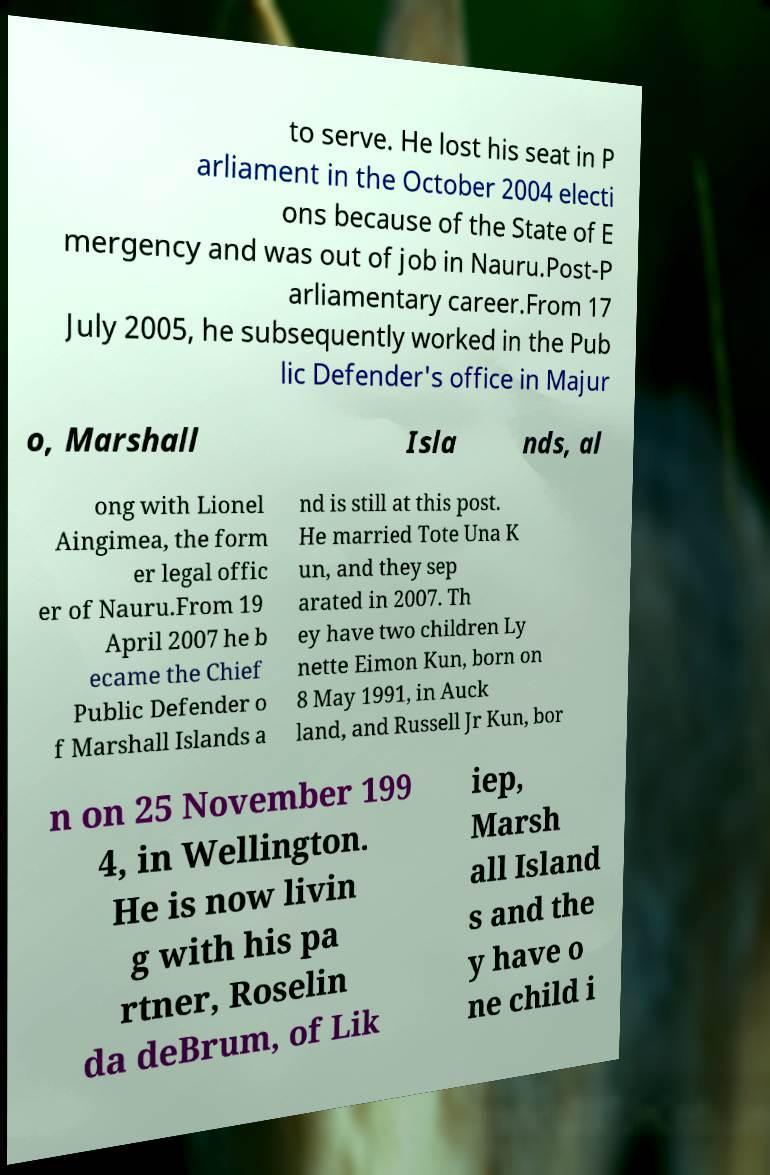For documentation purposes, I need the text within this image transcribed. Could you provide that? to serve. He lost his seat in P arliament in the October 2004 electi ons because of the State of E mergency and was out of job in Nauru.Post-P arliamentary career.From 17 July 2005, he subsequently worked in the Pub lic Defender's office in Majur o, Marshall Isla nds, al ong with Lionel Aingimea, the form er legal offic er of Nauru.From 19 April 2007 he b ecame the Chief Public Defender o f Marshall Islands a nd is still at this post. He married Tote Una K un, and they sep arated in 2007. Th ey have two children Ly nette Eimon Kun, born on 8 May 1991, in Auck land, and Russell Jr Kun, bor n on 25 November 199 4, in Wellington. He is now livin g with his pa rtner, Roselin da deBrum, of Lik iep, Marsh all Island s and the y have o ne child i 